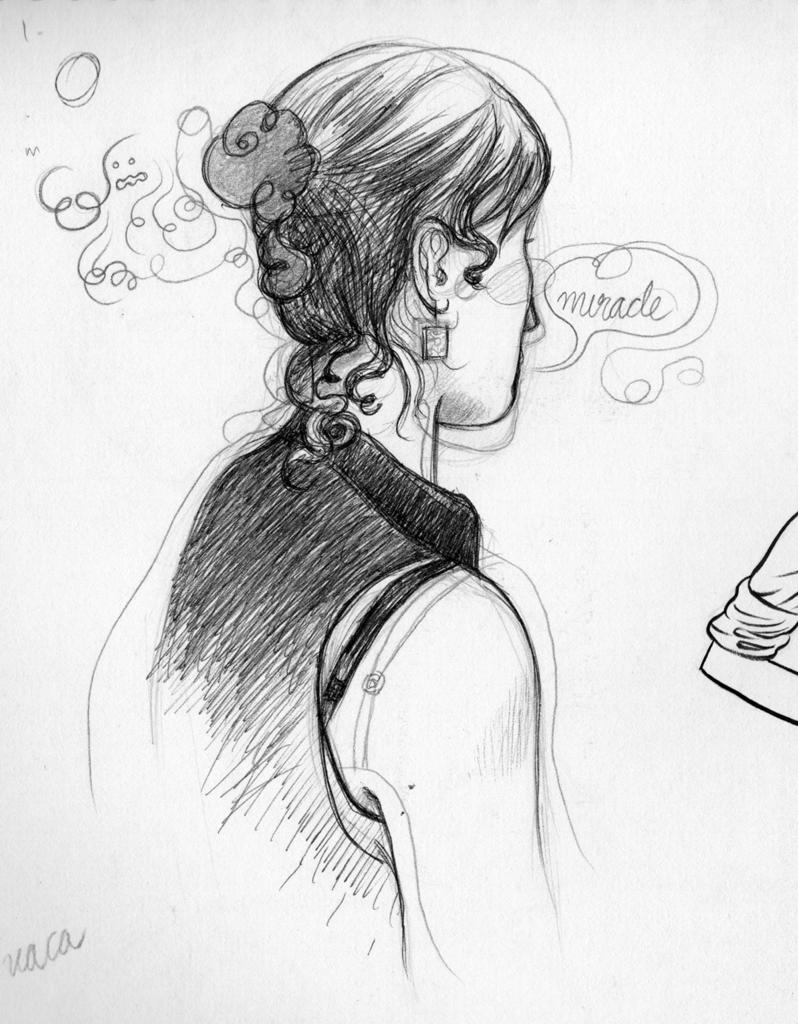What type of artwork is featured in the image? The image contains a pencil sketch. What subject is depicted in the pencil sketch? The pencil sketch is of a woman. What type of underwear is the woman wearing in the pencil sketch? There is no indication of the woman's underwear in the pencil sketch, as it is a drawing and not a photograph. Is there a volcano visible in the background of the pencil sketch? There is no volcano present in the pencil sketch; it only features a woman. What type of cord is used to frame the pencil sketch? There is no information about the type of cord used to frame the pencil sketch, as the facts only mention the sketch itself. 